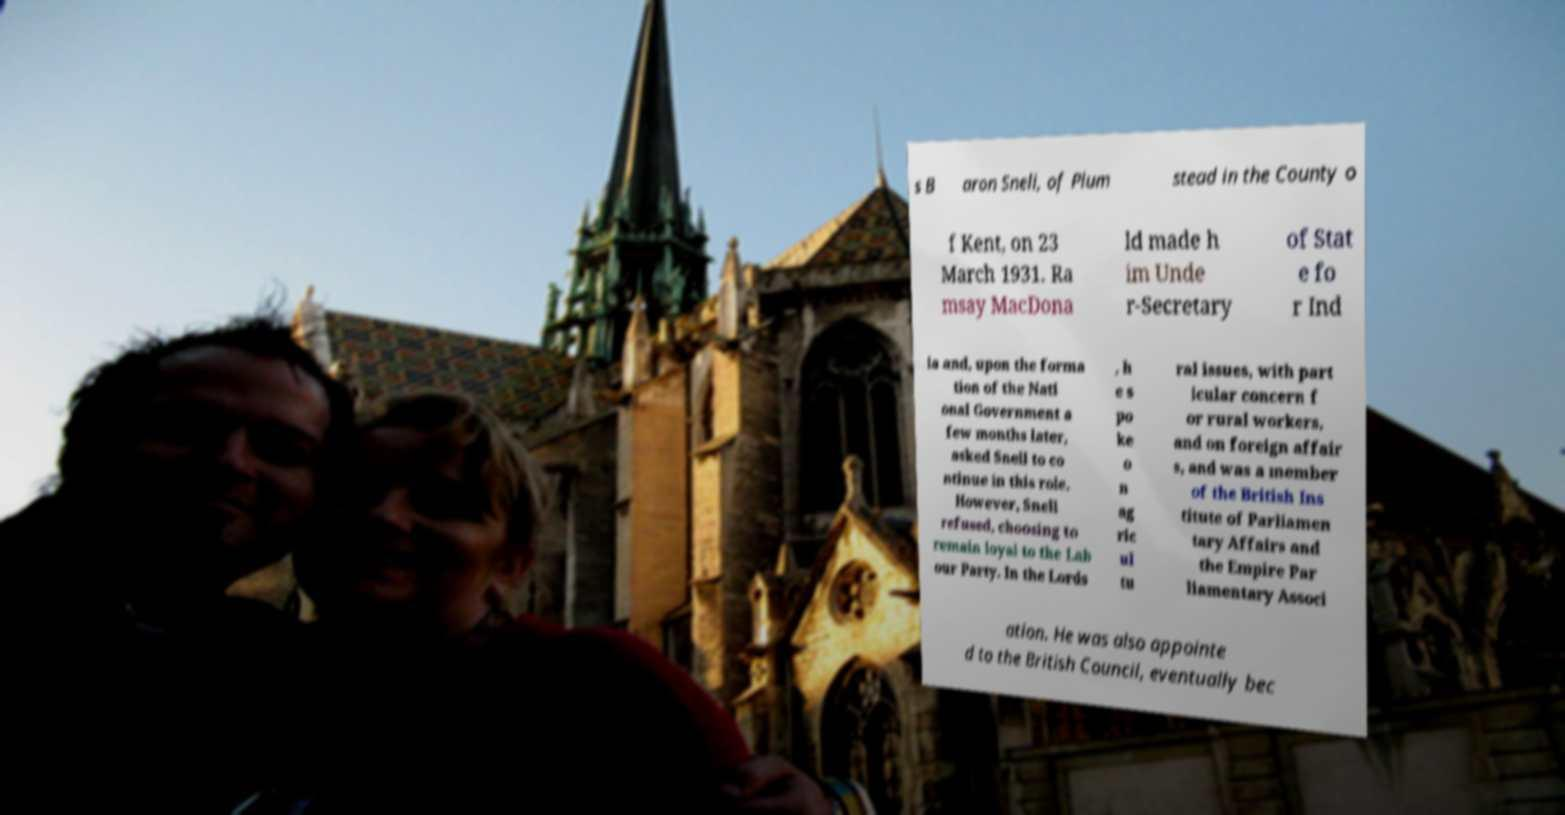Could you extract and type out the text from this image? s B aron Snell, of Plum stead in the County o f Kent, on 23 March 1931. Ra msay MacDona ld made h im Unde r-Secretary of Stat e fo r Ind ia and, upon the forma tion of the Nati onal Government a few months later, asked Snell to co ntinue in this role. However, Snell refused, choosing to remain loyal to the Lab our Party. In the Lords , h e s po ke o n ag ric ul tu ral issues, with part icular concern f or rural workers, and on foreign affair s, and was a member of the British Ins titute of Parliamen tary Affairs and the Empire Par liamentary Associ ation. He was also appointe d to the British Council, eventually bec 